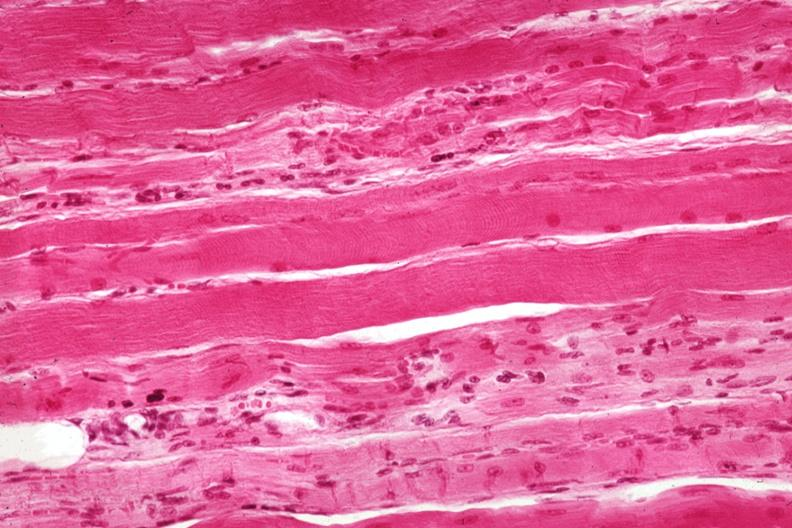does this image show good depiction focal fiber atrophy?
Answer the question using a single word or phrase. Yes 